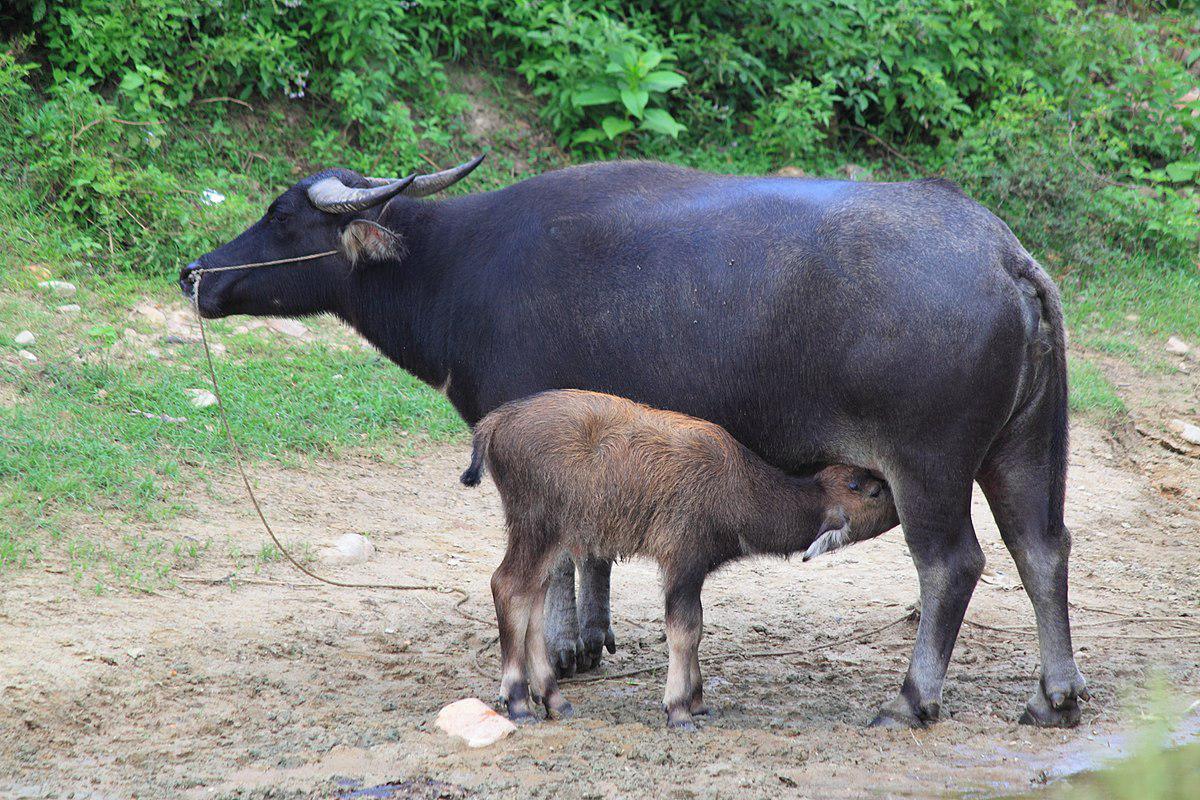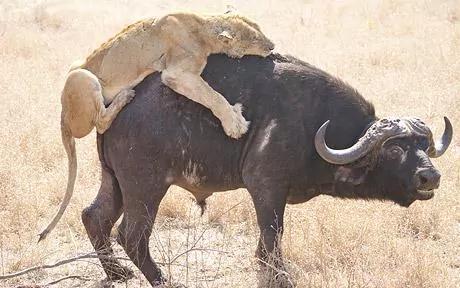The first image is the image on the left, the second image is the image on the right. Examine the images to the left and right. Is the description "At least one image shows a non-living water buffalo, with its actual flesh removed." accurate? Answer yes or no. No. The first image is the image on the left, the second image is the image on the right. Considering the images on both sides, is "water buffalo stare straight at the camera" valid? Answer yes or no. No. 